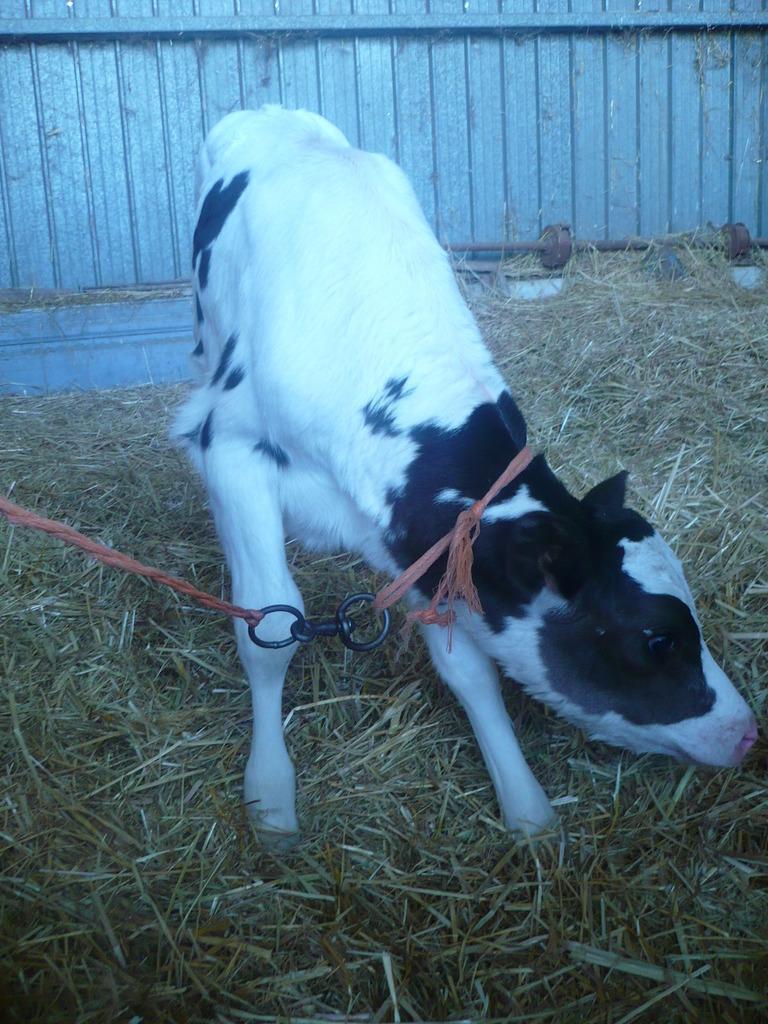In one or two sentences, can you explain what this image depicts? In this picture I can see a calf and I can see dry grass and I can see string to its neck and looks like a wall in the background. 